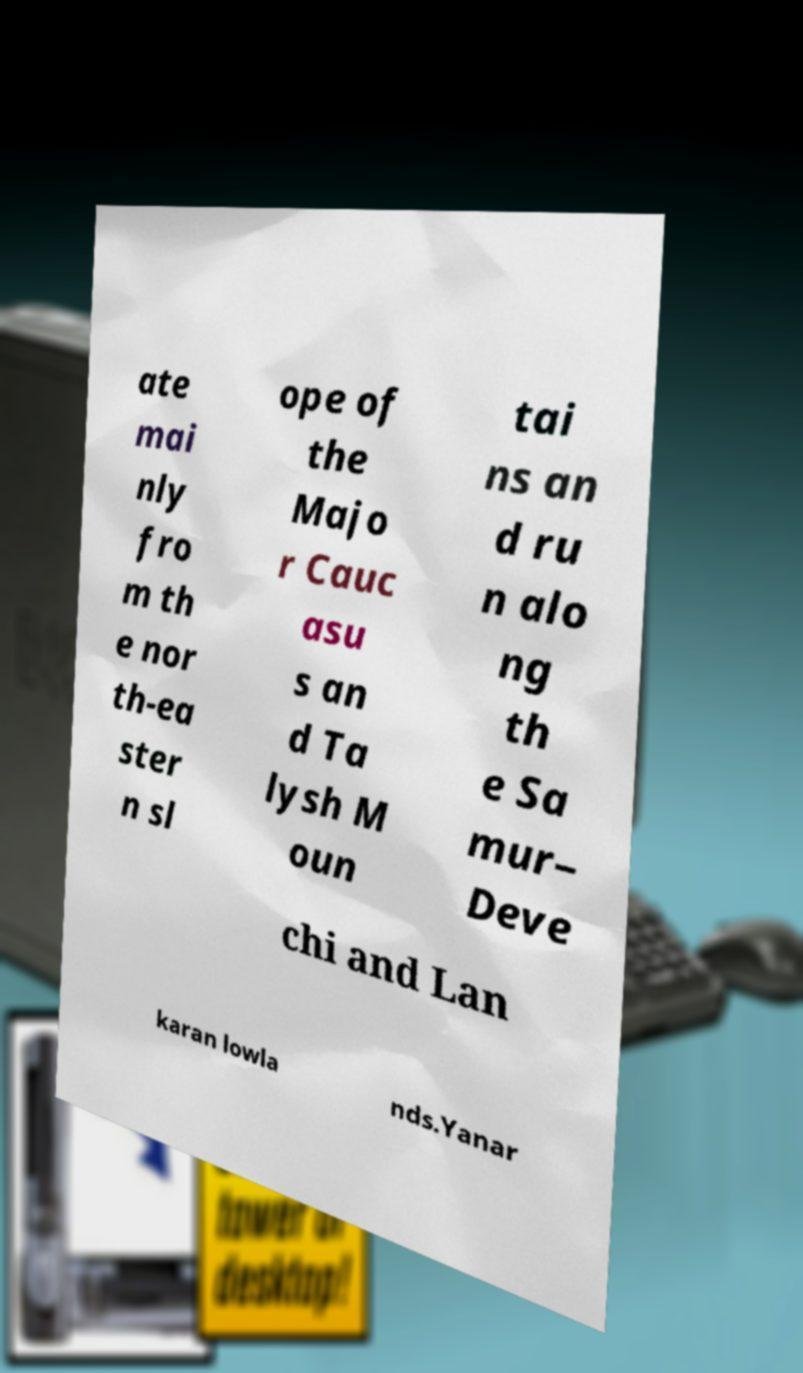For documentation purposes, I need the text within this image transcribed. Could you provide that? ate mai nly fro m th e nor th-ea ster n sl ope of the Majo r Cauc asu s an d Ta lysh M oun tai ns an d ru n alo ng th e Sa mur– Deve chi and Lan karan lowla nds.Yanar 